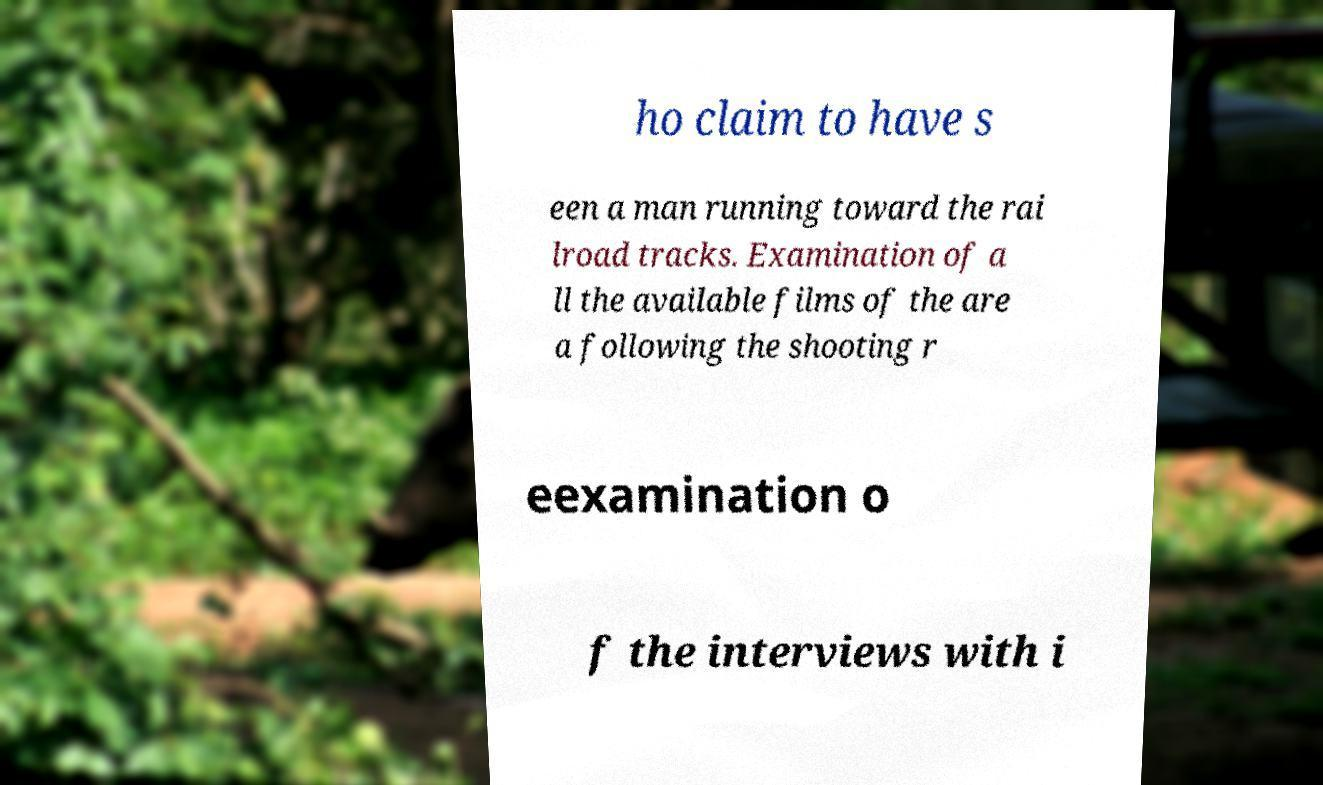What messages or text are displayed in this image? I need them in a readable, typed format. ho claim to have s een a man running toward the rai lroad tracks. Examination of a ll the available films of the are a following the shooting r eexamination o f the interviews with i 